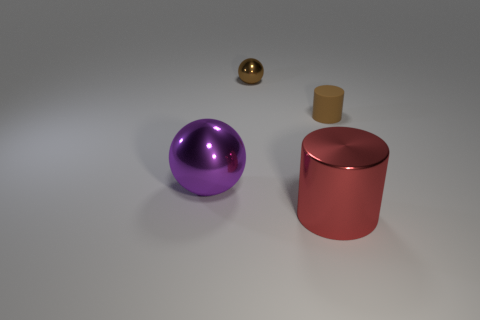Is there any other thing that is made of the same material as the tiny brown cylinder?
Provide a short and direct response. No. What number of objects are either brown matte objects that are to the right of the tiny brown sphere or shiny objects that are to the right of the large purple metallic object?
Provide a short and direct response. 3. There is a object on the right side of the red object; is its shape the same as the small brown thing to the left of the brown cylinder?
Your answer should be compact. No. What is the shape of the other object that is the same size as the purple thing?
Make the answer very short. Cylinder. What number of matte things are big purple balls or red cylinders?
Your response must be concise. 0. Is the big object that is behind the red metallic cylinder made of the same material as the brown thing that is left of the red shiny object?
Offer a very short reply. Yes. There is another small thing that is made of the same material as the purple thing; what is its color?
Ensure brevity in your answer.  Brown. Are there more big red shiny cylinders that are right of the large shiny ball than large purple objects that are behind the brown cylinder?
Ensure brevity in your answer.  Yes. Is there a yellow shiny cube?
Ensure brevity in your answer.  No. There is a small object that is the same color as the tiny cylinder; what material is it?
Your response must be concise. Metal. 